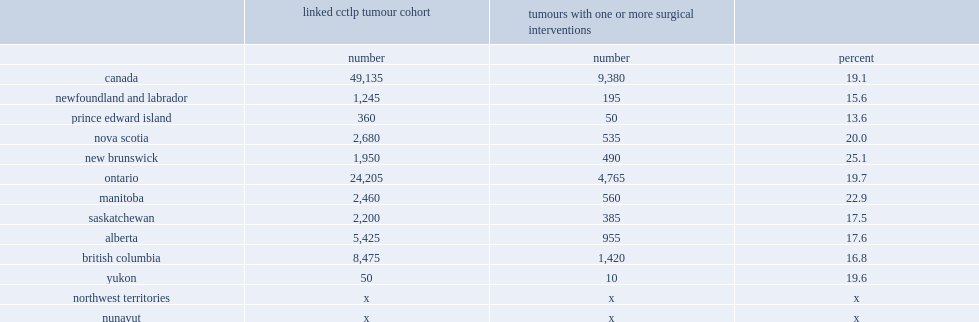List the province where the surgical rate is lowest and the number of the rate. Prince edward island 13.6. List the province where the surgical rate is highest and the number of the rate. New brunswick 25.1. 